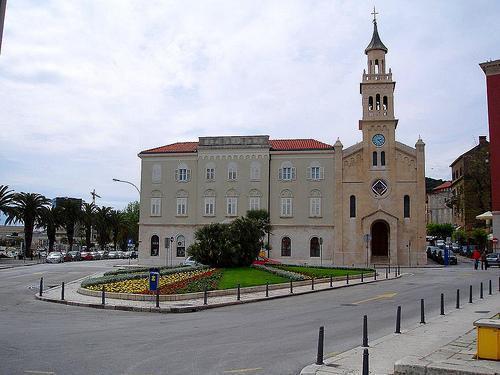How many people are in this photo?
Give a very brief answer. 2. 